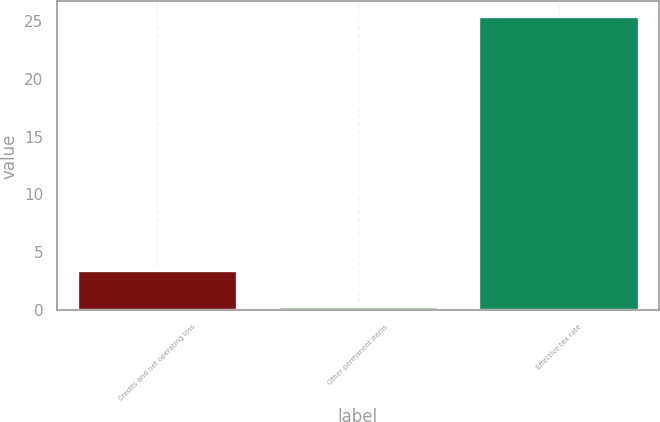<chart> <loc_0><loc_0><loc_500><loc_500><bar_chart><fcel>Credits and net operating loss<fcel>Other permanent items<fcel>Effective tax rate<nl><fcel>3.5<fcel>0.4<fcel>25.4<nl></chart> 